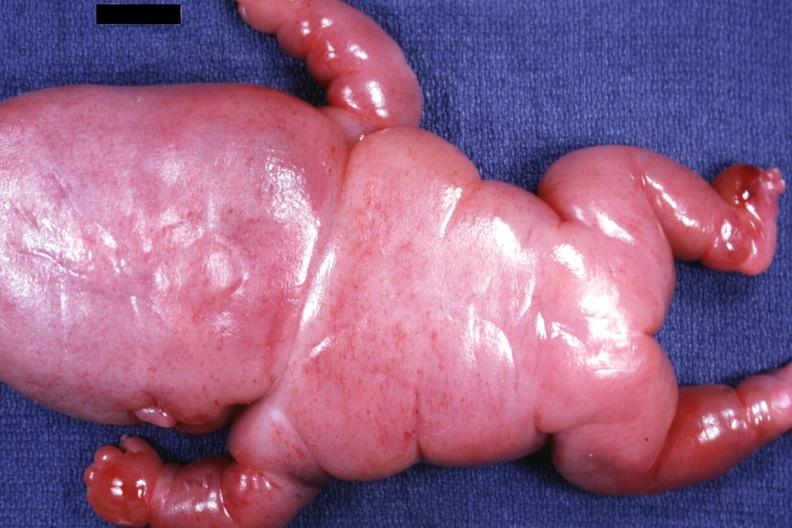what is present?
Answer the question using a single word or phrase. Lymphangiomatosis generalized 